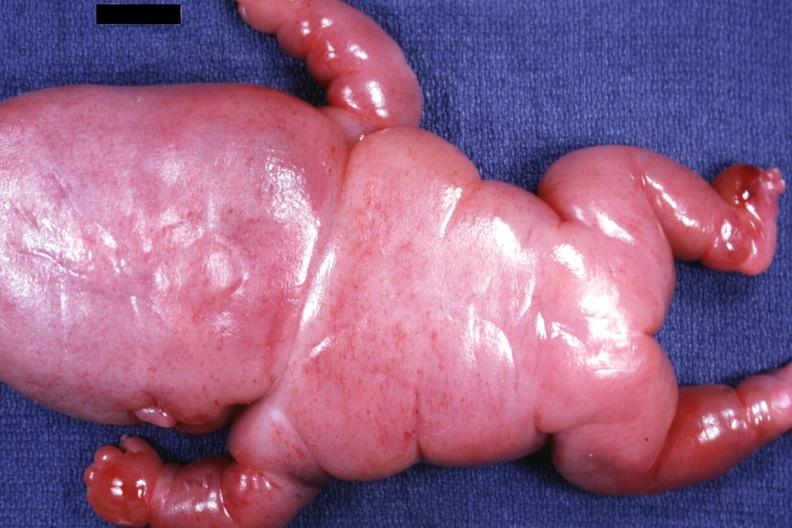what is present?
Answer the question using a single word or phrase. Lymphangiomatosis generalized 